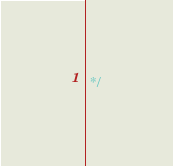Convert code to text. <code><loc_0><loc_0><loc_500><loc_500><_SQL_> */</code> 